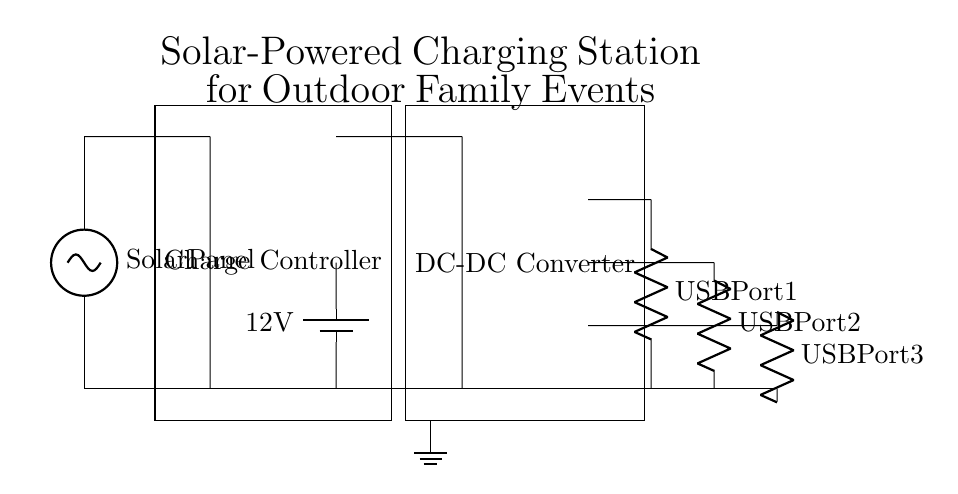What is the primary power source for this charging station? The primary power source is a solar panel, indicated at the left side of the diagram. It converts sunlight into electricity for the circuit.
Answer: Solar Panel What is the purpose of the charge controller? The charge controller regulates the charging of the battery to prevent overcharging and ensures proper energy flow from the solar panel to the battery.
Answer: Regulate charging What is the output voltage of the battery depicted in the circuit? The output voltage of the battery is labeled as twelve volts in the diagram, providing the necessary voltage for the connected components.
Answer: 12 volts How many USB ports are available for charging devices? There are three USB ports available for charging, each is indicated by separate resistive symbols marked as USB Port 1, USB Port 2, and USB Port 3.
Answer: Three What device is used to convert the battery output to a usable voltage for USB ports? The DC-DC converter converts the battery output to a usable voltage suitable for charging through the USB ports, ensuring that devices receive the correct voltage.
Answer: DC-DC Converter Why is grounding important in this circuit? Grounding is important to provide a safe path for excess current to flow to the earth, reducing the risk of electrical shock and ensuring stable operation of the circuit.
Answer: Safety What is the function of the resistive components connected to the USB ports? The resistive components indicate the presence of load or connection point for each USB port, allowing devices to be charged by limiting the current flowing to them.
Answer: Current limitation 